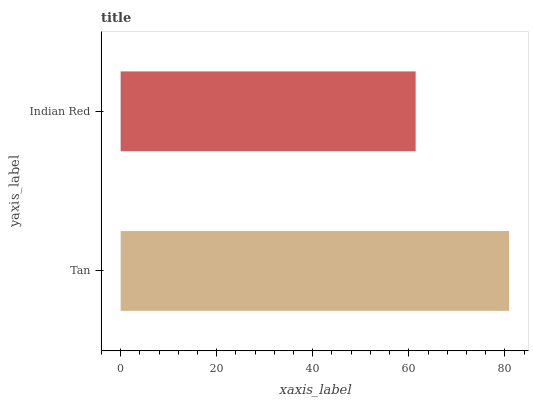Is Indian Red the minimum?
Answer yes or no. Yes. Is Tan the maximum?
Answer yes or no. Yes. Is Indian Red the maximum?
Answer yes or no. No. Is Tan greater than Indian Red?
Answer yes or no. Yes. Is Indian Red less than Tan?
Answer yes or no. Yes. Is Indian Red greater than Tan?
Answer yes or no. No. Is Tan less than Indian Red?
Answer yes or no. No. Is Tan the high median?
Answer yes or no. Yes. Is Indian Red the low median?
Answer yes or no. Yes. Is Indian Red the high median?
Answer yes or no. No. Is Tan the low median?
Answer yes or no. No. 